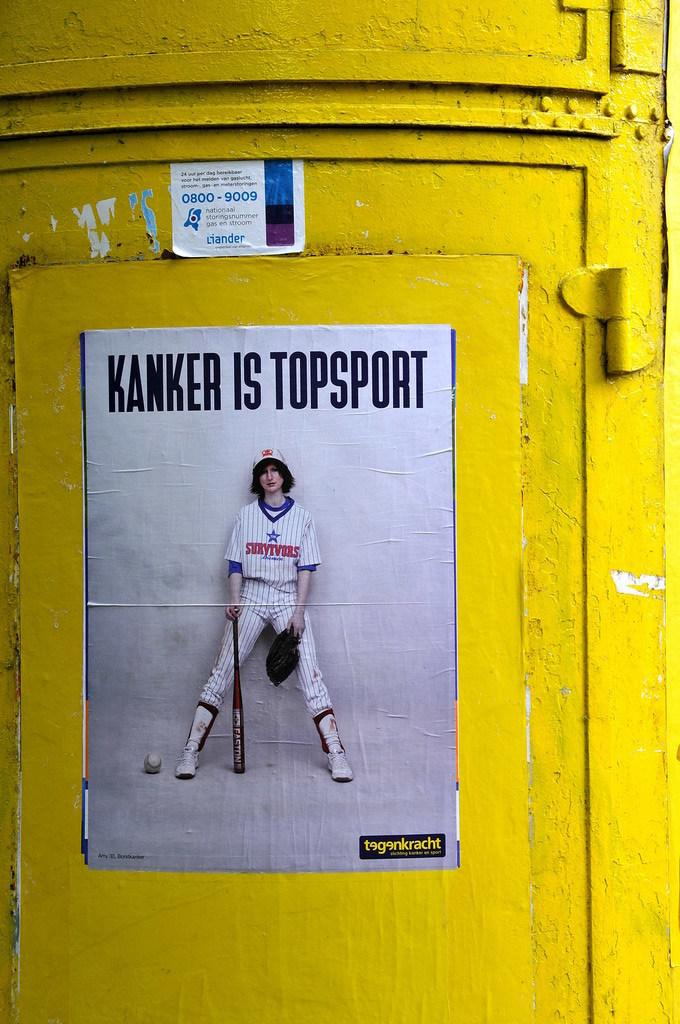<image>
Share a concise interpretation of the image provided. White poster which says "Kanker is Topsport" on a yellow obstacle. 